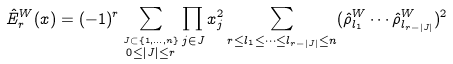Convert formula to latex. <formula><loc_0><loc_0><loc_500><loc_500>\hat { E } ^ { W } _ { r } ( x ) = ( - 1 ) ^ { r } \sum _ { \stackrel { J \subset \{ 1 , \dots , n \} } { 0 \leq | J | \leq r } } \prod _ { j \in J } x _ { j } ^ { 2 } \sum _ { r \leq l _ { 1 } \leq \cdots \leq l _ { r - | J | } \leq n } ( \hat { \rho } ^ { W } _ { l _ { 1 } } \cdots \hat { \rho } ^ { W } _ { l _ { r - | J | } } ) ^ { 2 }</formula> 